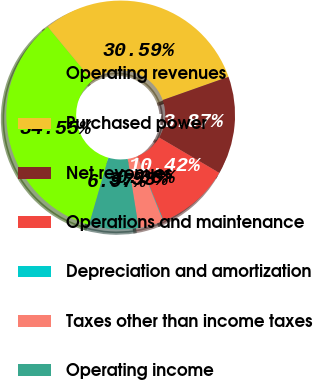Convert chart to OTSL. <chart><loc_0><loc_0><loc_500><loc_500><pie_chart><fcel>Operating revenues<fcel>Purchased power<fcel>Net revenues<fcel>Operations and maintenance<fcel>Depreciation and amortization<fcel>Taxes other than income taxes<fcel>Operating income<nl><fcel>34.55%<fcel>30.59%<fcel>13.87%<fcel>10.42%<fcel>0.08%<fcel>3.53%<fcel>6.97%<nl></chart> 